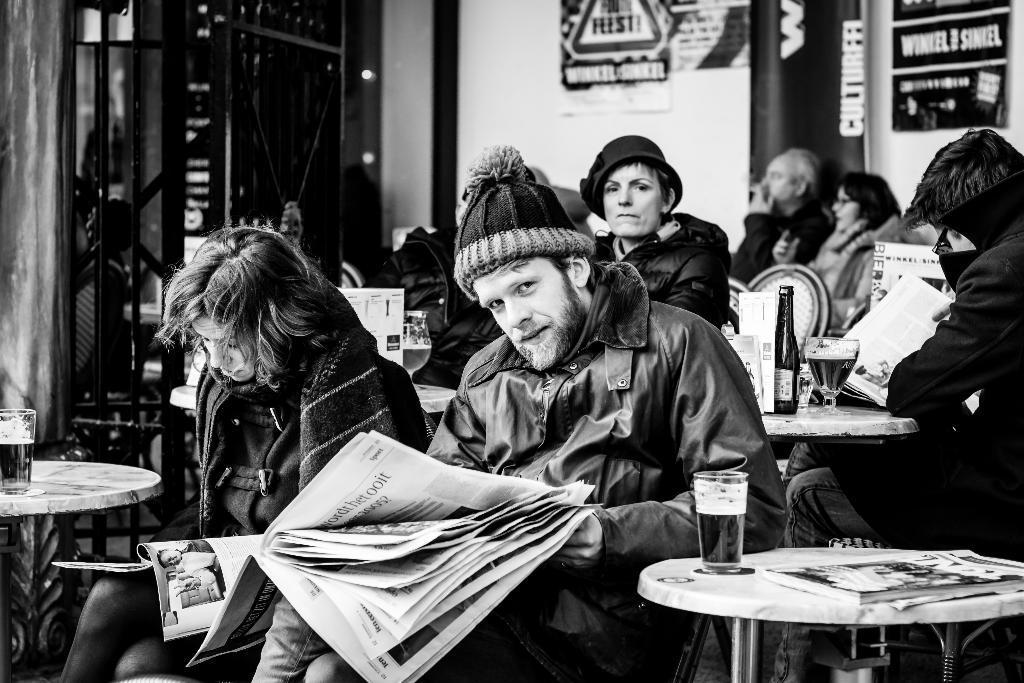In one or two sentences, can you explain what this image depicts? In the image we can see there are people who are sitting on chair in front of them there is a table on which there are wine glass and wine bottle and the image is in black and white colour. 